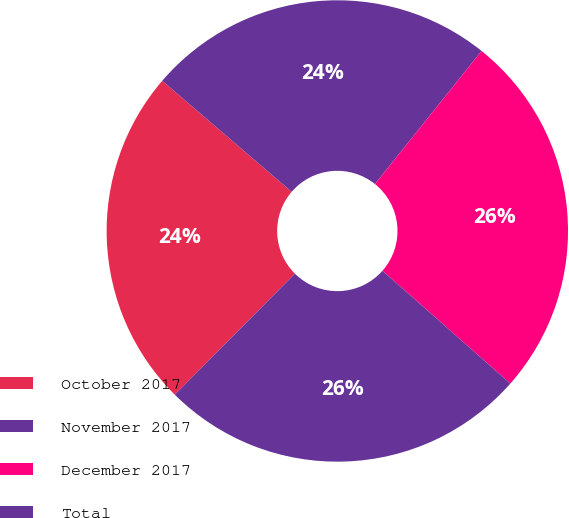Convert chart to OTSL. <chart><loc_0><loc_0><loc_500><loc_500><pie_chart><fcel>October 2017<fcel>November 2017<fcel>December 2017<fcel>Total<nl><fcel>23.84%<fcel>24.47%<fcel>25.75%<fcel>25.94%<nl></chart> 